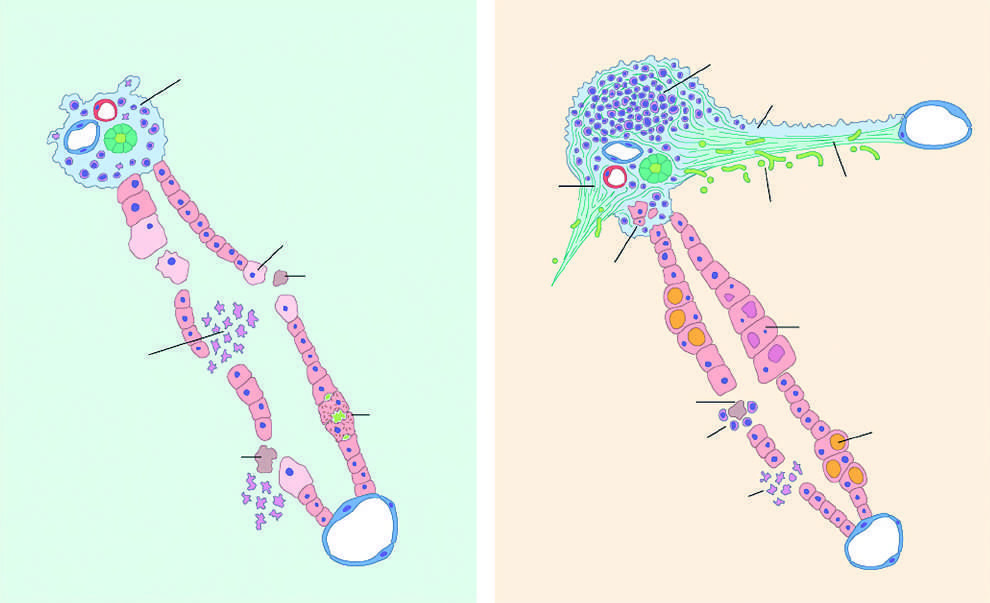what is there in acute hepatitis?
Answer the question using a single word or phrase. Very little portal mononuclear infiltration 